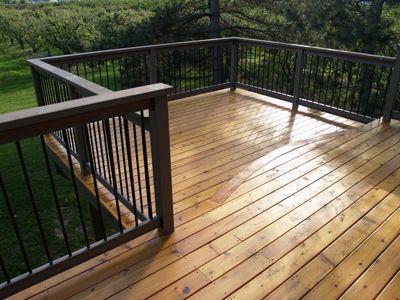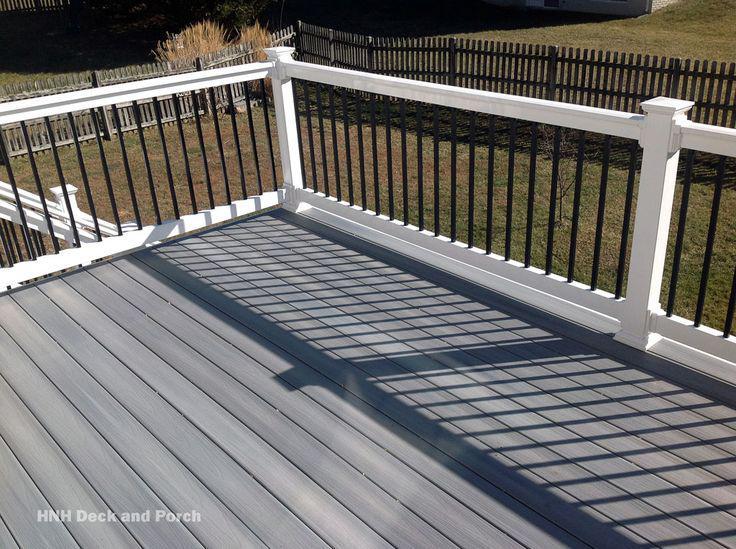The first image is the image on the left, the second image is the image on the right. Analyze the images presented: Is the assertion "One of the railings is black and white." valid? Answer yes or no. Yes. The first image is the image on the left, the second image is the image on the right. Examine the images to the left and right. Is the description "A wooden deck has bright white rails with black balusters." accurate? Answer yes or no. Yes. 